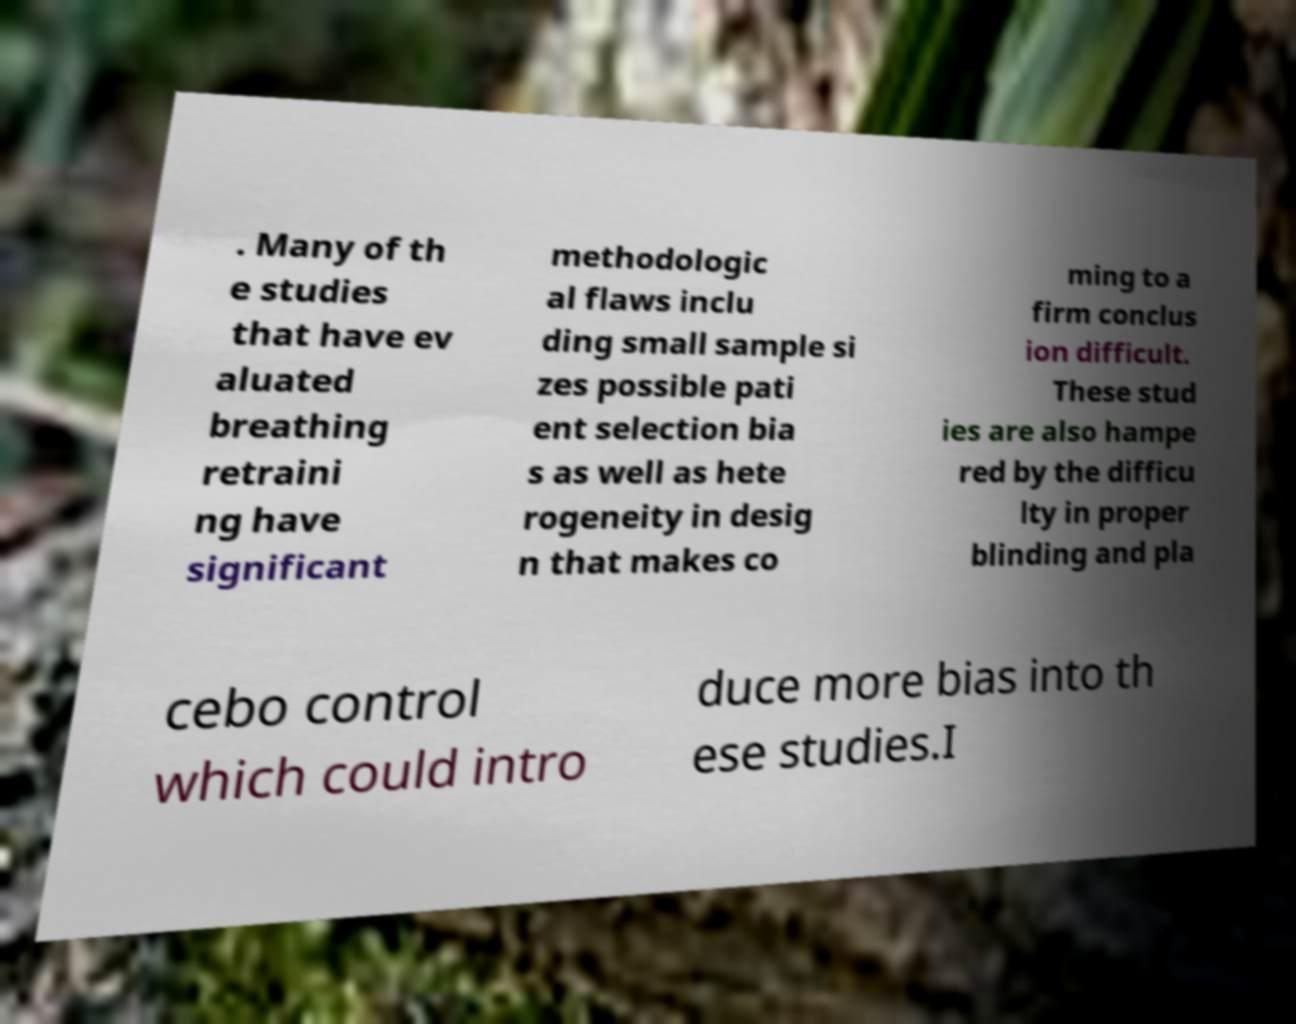For documentation purposes, I need the text within this image transcribed. Could you provide that? . Many of th e studies that have ev aluated breathing retraini ng have significant methodologic al flaws inclu ding small sample si zes possible pati ent selection bia s as well as hete rogeneity in desig n that makes co ming to a firm conclus ion difficult. These stud ies are also hampe red by the difficu lty in proper blinding and pla cebo control which could intro duce more bias into th ese studies.I 